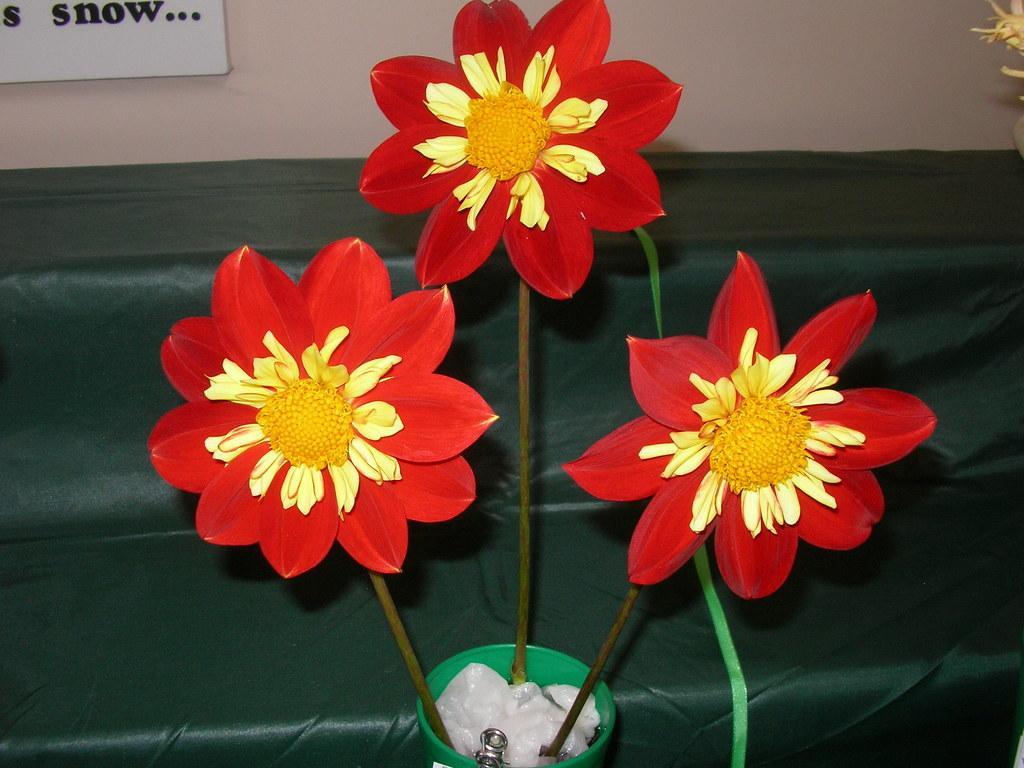Describe this image in one or two sentences. In this image, we can see flowers in the pot and there are some papers. In the background, there is a cloth and there is a board on the wall. 